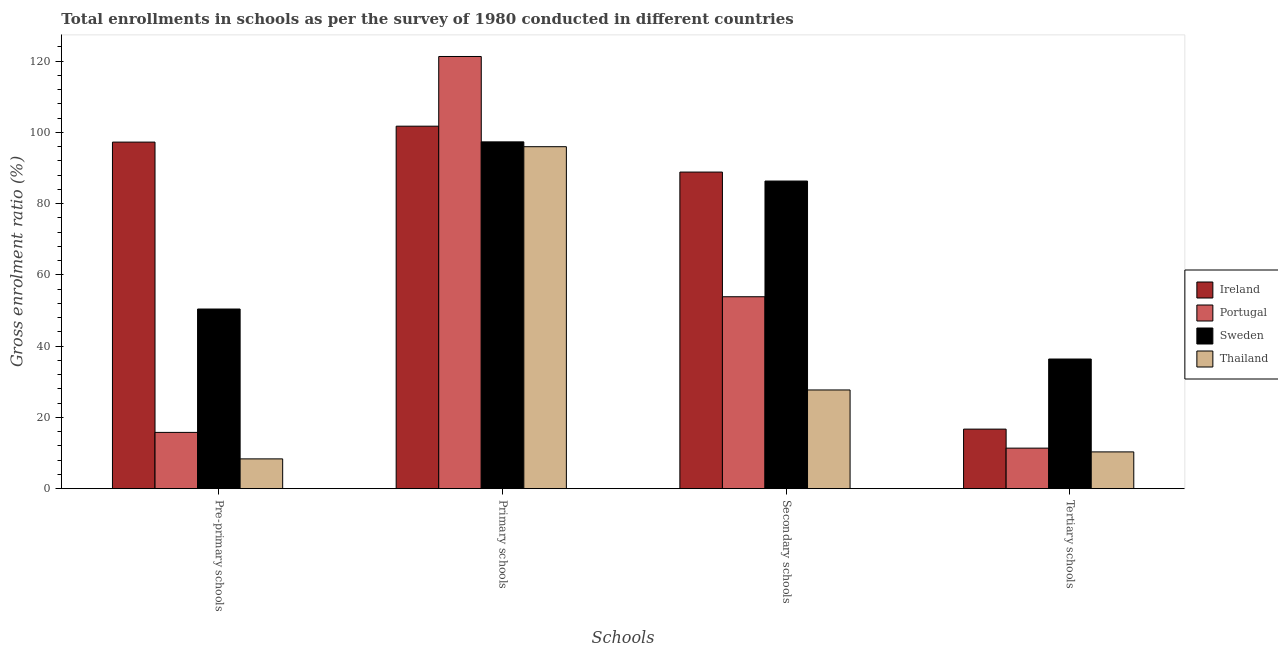How many different coloured bars are there?
Keep it short and to the point. 4. How many groups of bars are there?
Keep it short and to the point. 4. Are the number of bars on each tick of the X-axis equal?
Your answer should be very brief. Yes. How many bars are there on the 1st tick from the right?
Give a very brief answer. 4. What is the label of the 2nd group of bars from the left?
Make the answer very short. Primary schools. What is the gross enrolment ratio in secondary schools in Thailand?
Give a very brief answer. 27.7. Across all countries, what is the maximum gross enrolment ratio in tertiary schools?
Make the answer very short. 36.38. Across all countries, what is the minimum gross enrolment ratio in primary schools?
Ensure brevity in your answer.  95.97. In which country was the gross enrolment ratio in tertiary schools minimum?
Your answer should be compact. Thailand. What is the total gross enrolment ratio in primary schools in the graph?
Your answer should be very brief. 416.29. What is the difference between the gross enrolment ratio in secondary schools in Sweden and that in Ireland?
Provide a succinct answer. -2.52. What is the difference between the gross enrolment ratio in tertiary schools in Sweden and the gross enrolment ratio in pre-primary schools in Portugal?
Your answer should be very brief. 20.59. What is the average gross enrolment ratio in tertiary schools per country?
Offer a terse response. 18.7. What is the difference between the gross enrolment ratio in secondary schools and gross enrolment ratio in primary schools in Thailand?
Offer a terse response. -68.27. In how many countries, is the gross enrolment ratio in primary schools greater than 88 %?
Give a very brief answer. 4. What is the ratio of the gross enrolment ratio in primary schools in Portugal to that in Sweden?
Offer a very short reply. 1.25. Is the difference between the gross enrolment ratio in primary schools in Ireland and Thailand greater than the difference between the gross enrolment ratio in tertiary schools in Ireland and Thailand?
Give a very brief answer. No. What is the difference between the highest and the second highest gross enrolment ratio in pre-primary schools?
Your answer should be compact. 46.84. What is the difference between the highest and the lowest gross enrolment ratio in pre-primary schools?
Keep it short and to the point. 88.89. In how many countries, is the gross enrolment ratio in tertiary schools greater than the average gross enrolment ratio in tertiary schools taken over all countries?
Your answer should be very brief. 1. Is it the case that in every country, the sum of the gross enrolment ratio in tertiary schools and gross enrolment ratio in pre-primary schools is greater than the sum of gross enrolment ratio in secondary schools and gross enrolment ratio in primary schools?
Your answer should be compact. No. What does the 3rd bar from the left in Tertiary schools represents?
Offer a terse response. Sweden. What does the 2nd bar from the right in Secondary schools represents?
Your answer should be compact. Sweden. Is it the case that in every country, the sum of the gross enrolment ratio in pre-primary schools and gross enrolment ratio in primary schools is greater than the gross enrolment ratio in secondary schools?
Your answer should be very brief. Yes. How many countries are there in the graph?
Ensure brevity in your answer.  4. What is the difference between two consecutive major ticks on the Y-axis?
Provide a succinct answer. 20. Are the values on the major ticks of Y-axis written in scientific E-notation?
Keep it short and to the point. No. Does the graph contain any zero values?
Provide a short and direct response. No. Does the graph contain grids?
Provide a succinct answer. No. Where does the legend appear in the graph?
Give a very brief answer. Center right. How are the legend labels stacked?
Give a very brief answer. Vertical. What is the title of the graph?
Provide a short and direct response. Total enrollments in schools as per the survey of 1980 conducted in different countries. Does "Antigua and Barbuda" appear as one of the legend labels in the graph?
Offer a very short reply. No. What is the label or title of the X-axis?
Your answer should be very brief. Schools. What is the Gross enrolment ratio (%) of Ireland in Pre-primary schools?
Make the answer very short. 97.25. What is the Gross enrolment ratio (%) in Portugal in Pre-primary schools?
Your response must be concise. 15.79. What is the Gross enrolment ratio (%) in Sweden in Pre-primary schools?
Your response must be concise. 50.41. What is the Gross enrolment ratio (%) of Thailand in Pre-primary schools?
Offer a very short reply. 8.36. What is the Gross enrolment ratio (%) of Ireland in Primary schools?
Offer a terse response. 101.72. What is the Gross enrolment ratio (%) in Portugal in Primary schools?
Ensure brevity in your answer.  121.28. What is the Gross enrolment ratio (%) in Sweden in Primary schools?
Provide a succinct answer. 97.32. What is the Gross enrolment ratio (%) in Thailand in Primary schools?
Provide a short and direct response. 95.97. What is the Gross enrolment ratio (%) in Ireland in Secondary schools?
Your answer should be very brief. 88.84. What is the Gross enrolment ratio (%) of Portugal in Secondary schools?
Your response must be concise. 53.86. What is the Gross enrolment ratio (%) of Sweden in Secondary schools?
Provide a succinct answer. 86.33. What is the Gross enrolment ratio (%) of Thailand in Secondary schools?
Your response must be concise. 27.7. What is the Gross enrolment ratio (%) of Ireland in Tertiary schools?
Provide a short and direct response. 16.71. What is the Gross enrolment ratio (%) in Portugal in Tertiary schools?
Ensure brevity in your answer.  11.38. What is the Gross enrolment ratio (%) of Sweden in Tertiary schools?
Provide a short and direct response. 36.38. What is the Gross enrolment ratio (%) in Thailand in Tertiary schools?
Offer a very short reply. 10.32. Across all Schools, what is the maximum Gross enrolment ratio (%) in Ireland?
Offer a terse response. 101.72. Across all Schools, what is the maximum Gross enrolment ratio (%) in Portugal?
Provide a succinct answer. 121.28. Across all Schools, what is the maximum Gross enrolment ratio (%) in Sweden?
Your answer should be very brief. 97.32. Across all Schools, what is the maximum Gross enrolment ratio (%) in Thailand?
Your answer should be very brief. 95.97. Across all Schools, what is the minimum Gross enrolment ratio (%) in Ireland?
Offer a very short reply. 16.71. Across all Schools, what is the minimum Gross enrolment ratio (%) in Portugal?
Offer a very short reply. 11.38. Across all Schools, what is the minimum Gross enrolment ratio (%) of Sweden?
Make the answer very short. 36.38. Across all Schools, what is the minimum Gross enrolment ratio (%) in Thailand?
Your answer should be compact. 8.36. What is the total Gross enrolment ratio (%) of Ireland in the graph?
Ensure brevity in your answer.  304.53. What is the total Gross enrolment ratio (%) of Portugal in the graph?
Make the answer very short. 202.31. What is the total Gross enrolment ratio (%) in Sweden in the graph?
Keep it short and to the point. 270.44. What is the total Gross enrolment ratio (%) of Thailand in the graph?
Offer a terse response. 142.34. What is the difference between the Gross enrolment ratio (%) of Ireland in Pre-primary schools and that in Primary schools?
Make the answer very short. -4.47. What is the difference between the Gross enrolment ratio (%) of Portugal in Pre-primary schools and that in Primary schools?
Provide a succinct answer. -105.49. What is the difference between the Gross enrolment ratio (%) in Sweden in Pre-primary schools and that in Primary schools?
Your answer should be very brief. -46.91. What is the difference between the Gross enrolment ratio (%) of Thailand in Pre-primary schools and that in Primary schools?
Provide a short and direct response. -87.61. What is the difference between the Gross enrolment ratio (%) of Ireland in Pre-primary schools and that in Secondary schools?
Your answer should be very brief. 8.41. What is the difference between the Gross enrolment ratio (%) in Portugal in Pre-primary schools and that in Secondary schools?
Offer a very short reply. -38.07. What is the difference between the Gross enrolment ratio (%) in Sweden in Pre-primary schools and that in Secondary schools?
Ensure brevity in your answer.  -35.92. What is the difference between the Gross enrolment ratio (%) of Thailand in Pre-primary schools and that in Secondary schools?
Offer a terse response. -19.34. What is the difference between the Gross enrolment ratio (%) of Ireland in Pre-primary schools and that in Tertiary schools?
Your answer should be compact. 80.54. What is the difference between the Gross enrolment ratio (%) in Portugal in Pre-primary schools and that in Tertiary schools?
Your answer should be very brief. 4.41. What is the difference between the Gross enrolment ratio (%) in Sweden in Pre-primary schools and that in Tertiary schools?
Your answer should be compact. 14.03. What is the difference between the Gross enrolment ratio (%) of Thailand in Pre-primary schools and that in Tertiary schools?
Offer a terse response. -1.96. What is the difference between the Gross enrolment ratio (%) of Ireland in Primary schools and that in Secondary schools?
Ensure brevity in your answer.  12.88. What is the difference between the Gross enrolment ratio (%) of Portugal in Primary schools and that in Secondary schools?
Ensure brevity in your answer.  67.42. What is the difference between the Gross enrolment ratio (%) of Sweden in Primary schools and that in Secondary schools?
Make the answer very short. 10.99. What is the difference between the Gross enrolment ratio (%) of Thailand in Primary schools and that in Secondary schools?
Provide a succinct answer. 68.27. What is the difference between the Gross enrolment ratio (%) in Ireland in Primary schools and that in Tertiary schools?
Your answer should be compact. 85.01. What is the difference between the Gross enrolment ratio (%) of Portugal in Primary schools and that in Tertiary schools?
Make the answer very short. 109.9. What is the difference between the Gross enrolment ratio (%) in Sweden in Primary schools and that in Tertiary schools?
Your response must be concise. 60.94. What is the difference between the Gross enrolment ratio (%) in Thailand in Primary schools and that in Tertiary schools?
Provide a succinct answer. 85.65. What is the difference between the Gross enrolment ratio (%) of Ireland in Secondary schools and that in Tertiary schools?
Make the answer very short. 72.13. What is the difference between the Gross enrolment ratio (%) of Portugal in Secondary schools and that in Tertiary schools?
Offer a very short reply. 42.48. What is the difference between the Gross enrolment ratio (%) of Sweden in Secondary schools and that in Tertiary schools?
Provide a short and direct response. 49.95. What is the difference between the Gross enrolment ratio (%) in Thailand in Secondary schools and that in Tertiary schools?
Your answer should be very brief. 17.38. What is the difference between the Gross enrolment ratio (%) of Ireland in Pre-primary schools and the Gross enrolment ratio (%) of Portugal in Primary schools?
Keep it short and to the point. -24.03. What is the difference between the Gross enrolment ratio (%) of Ireland in Pre-primary schools and the Gross enrolment ratio (%) of Sweden in Primary schools?
Provide a succinct answer. -0.06. What is the difference between the Gross enrolment ratio (%) in Ireland in Pre-primary schools and the Gross enrolment ratio (%) in Thailand in Primary schools?
Keep it short and to the point. 1.29. What is the difference between the Gross enrolment ratio (%) of Portugal in Pre-primary schools and the Gross enrolment ratio (%) of Sweden in Primary schools?
Make the answer very short. -81.53. What is the difference between the Gross enrolment ratio (%) in Portugal in Pre-primary schools and the Gross enrolment ratio (%) in Thailand in Primary schools?
Your answer should be very brief. -80.17. What is the difference between the Gross enrolment ratio (%) of Sweden in Pre-primary schools and the Gross enrolment ratio (%) of Thailand in Primary schools?
Give a very brief answer. -45.55. What is the difference between the Gross enrolment ratio (%) of Ireland in Pre-primary schools and the Gross enrolment ratio (%) of Portugal in Secondary schools?
Your answer should be very brief. 43.39. What is the difference between the Gross enrolment ratio (%) of Ireland in Pre-primary schools and the Gross enrolment ratio (%) of Sweden in Secondary schools?
Offer a very short reply. 10.93. What is the difference between the Gross enrolment ratio (%) in Ireland in Pre-primary schools and the Gross enrolment ratio (%) in Thailand in Secondary schools?
Ensure brevity in your answer.  69.55. What is the difference between the Gross enrolment ratio (%) in Portugal in Pre-primary schools and the Gross enrolment ratio (%) in Sweden in Secondary schools?
Provide a short and direct response. -70.54. What is the difference between the Gross enrolment ratio (%) of Portugal in Pre-primary schools and the Gross enrolment ratio (%) of Thailand in Secondary schools?
Ensure brevity in your answer.  -11.91. What is the difference between the Gross enrolment ratio (%) of Sweden in Pre-primary schools and the Gross enrolment ratio (%) of Thailand in Secondary schools?
Provide a succinct answer. 22.71. What is the difference between the Gross enrolment ratio (%) of Ireland in Pre-primary schools and the Gross enrolment ratio (%) of Portugal in Tertiary schools?
Provide a succinct answer. 85.88. What is the difference between the Gross enrolment ratio (%) in Ireland in Pre-primary schools and the Gross enrolment ratio (%) in Sweden in Tertiary schools?
Your answer should be very brief. 60.87. What is the difference between the Gross enrolment ratio (%) of Ireland in Pre-primary schools and the Gross enrolment ratio (%) of Thailand in Tertiary schools?
Your answer should be compact. 86.93. What is the difference between the Gross enrolment ratio (%) in Portugal in Pre-primary schools and the Gross enrolment ratio (%) in Sweden in Tertiary schools?
Provide a short and direct response. -20.59. What is the difference between the Gross enrolment ratio (%) of Portugal in Pre-primary schools and the Gross enrolment ratio (%) of Thailand in Tertiary schools?
Give a very brief answer. 5.47. What is the difference between the Gross enrolment ratio (%) of Sweden in Pre-primary schools and the Gross enrolment ratio (%) of Thailand in Tertiary schools?
Your response must be concise. 40.09. What is the difference between the Gross enrolment ratio (%) of Ireland in Primary schools and the Gross enrolment ratio (%) of Portugal in Secondary schools?
Your response must be concise. 47.86. What is the difference between the Gross enrolment ratio (%) in Ireland in Primary schools and the Gross enrolment ratio (%) in Sweden in Secondary schools?
Your answer should be very brief. 15.39. What is the difference between the Gross enrolment ratio (%) in Ireland in Primary schools and the Gross enrolment ratio (%) in Thailand in Secondary schools?
Your response must be concise. 74.02. What is the difference between the Gross enrolment ratio (%) of Portugal in Primary schools and the Gross enrolment ratio (%) of Sweden in Secondary schools?
Your answer should be very brief. 34.95. What is the difference between the Gross enrolment ratio (%) in Portugal in Primary schools and the Gross enrolment ratio (%) in Thailand in Secondary schools?
Your answer should be very brief. 93.58. What is the difference between the Gross enrolment ratio (%) of Sweden in Primary schools and the Gross enrolment ratio (%) of Thailand in Secondary schools?
Offer a terse response. 69.62. What is the difference between the Gross enrolment ratio (%) in Ireland in Primary schools and the Gross enrolment ratio (%) in Portugal in Tertiary schools?
Provide a succinct answer. 90.34. What is the difference between the Gross enrolment ratio (%) of Ireland in Primary schools and the Gross enrolment ratio (%) of Sweden in Tertiary schools?
Your answer should be compact. 65.34. What is the difference between the Gross enrolment ratio (%) of Ireland in Primary schools and the Gross enrolment ratio (%) of Thailand in Tertiary schools?
Keep it short and to the point. 91.4. What is the difference between the Gross enrolment ratio (%) in Portugal in Primary schools and the Gross enrolment ratio (%) in Sweden in Tertiary schools?
Provide a succinct answer. 84.9. What is the difference between the Gross enrolment ratio (%) in Portugal in Primary schools and the Gross enrolment ratio (%) in Thailand in Tertiary schools?
Your answer should be very brief. 110.96. What is the difference between the Gross enrolment ratio (%) of Sweden in Primary schools and the Gross enrolment ratio (%) of Thailand in Tertiary schools?
Ensure brevity in your answer.  87. What is the difference between the Gross enrolment ratio (%) in Ireland in Secondary schools and the Gross enrolment ratio (%) in Portugal in Tertiary schools?
Offer a terse response. 77.47. What is the difference between the Gross enrolment ratio (%) in Ireland in Secondary schools and the Gross enrolment ratio (%) in Sweden in Tertiary schools?
Keep it short and to the point. 52.46. What is the difference between the Gross enrolment ratio (%) of Ireland in Secondary schools and the Gross enrolment ratio (%) of Thailand in Tertiary schools?
Your answer should be very brief. 78.52. What is the difference between the Gross enrolment ratio (%) of Portugal in Secondary schools and the Gross enrolment ratio (%) of Sweden in Tertiary schools?
Offer a terse response. 17.48. What is the difference between the Gross enrolment ratio (%) in Portugal in Secondary schools and the Gross enrolment ratio (%) in Thailand in Tertiary schools?
Make the answer very short. 43.54. What is the difference between the Gross enrolment ratio (%) of Sweden in Secondary schools and the Gross enrolment ratio (%) of Thailand in Tertiary schools?
Provide a short and direct response. 76.01. What is the average Gross enrolment ratio (%) in Ireland per Schools?
Offer a terse response. 76.13. What is the average Gross enrolment ratio (%) in Portugal per Schools?
Give a very brief answer. 50.58. What is the average Gross enrolment ratio (%) of Sweden per Schools?
Keep it short and to the point. 67.61. What is the average Gross enrolment ratio (%) in Thailand per Schools?
Provide a short and direct response. 35.59. What is the difference between the Gross enrolment ratio (%) in Ireland and Gross enrolment ratio (%) in Portugal in Pre-primary schools?
Provide a short and direct response. 81.46. What is the difference between the Gross enrolment ratio (%) in Ireland and Gross enrolment ratio (%) in Sweden in Pre-primary schools?
Offer a terse response. 46.84. What is the difference between the Gross enrolment ratio (%) in Ireland and Gross enrolment ratio (%) in Thailand in Pre-primary schools?
Offer a terse response. 88.89. What is the difference between the Gross enrolment ratio (%) of Portugal and Gross enrolment ratio (%) of Sweden in Pre-primary schools?
Give a very brief answer. -34.62. What is the difference between the Gross enrolment ratio (%) of Portugal and Gross enrolment ratio (%) of Thailand in Pre-primary schools?
Provide a succinct answer. 7.43. What is the difference between the Gross enrolment ratio (%) of Sweden and Gross enrolment ratio (%) of Thailand in Pre-primary schools?
Ensure brevity in your answer.  42.05. What is the difference between the Gross enrolment ratio (%) of Ireland and Gross enrolment ratio (%) of Portugal in Primary schools?
Ensure brevity in your answer.  -19.56. What is the difference between the Gross enrolment ratio (%) in Ireland and Gross enrolment ratio (%) in Sweden in Primary schools?
Ensure brevity in your answer.  4.4. What is the difference between the Gross enrolment ratio (%) in Ireland and Gross enrolment ratio (%) in Thailand in Primary schools?
Provide a short and direct response. 5.76. What is the difference between the Gross enrolment ratio (%) of Portugal and Gross enrolment ratio (%) of Sweden in Primary schools?
Offer a terse response. 23.96. What is the difference between the Gross enrolment ratio (%) in Portugal and Gross enrolment ratio (%) in Thailand in Primary schools?
Ensure brevity in your answer.  25.31. What is the difference between the Gross enrolment ratio (%) of Sweden and Gross enrolment ratio (%) of Thailand in Primary schools?
Your response must be concise. 1.35. What is the difference between the Gross enrolment ratio (%) in Ireland and Gross enrolment ratio (%) in Portugal in Secondary schools?
Ensure brevity in your answer.  34.98. What is the difference between the Gross enrolment ratio (%) of Ireland and Gross enrolment ratio (%) of Sweden in Secondary schools?
Provide a short and direct response. 2.52. What is the difference between the Gross enrolment ratio (%) of Ireland and Gross enrolment ratio (%) of Thailand in Secondary schools?
Provide a succinct answer. 61.14. What is the difference between the Gross enrolment ratio (%) of Portugal and Gross enrolment ratio (%) of Sweden in Secondary schools?
Your answer should be very brief. -32.47. What is the difference between the Gross enrolment ratio (%) of Portugal and Gross enrolment ratio (%) of Thailand in Secondary schools?
Provide a succinct answer. 26.16. What is the difference between the Gross enrolment ratio (%) of Sweden and Gross enrolment ratio (%) of Thailand in Secondary schools?
Offer a very short reply. 58.63. What is the difference between the Gross enrolment ratio (%) of Ireland and Gross enrolment ratio (%) of Portugal in Tertiary schools?
Make the answer very short. 5.33. What is the difference between the Gross enrolment ratio (%) in Ireland and Gross enrolment ratio (%) in Sweden in Tertiary schools?
Offer a terse response. -19.67. What is the difference between the Gross enrolment ratio (%) in Ireland and Gross enrolment ratio (%) in Thailand in Tertiary schools?
Your answer should be compact. 6.39. What is the difference between the Gross enrolment ratio (%) of Portugal and Gross enrolment ratio (%) of Sweden in Tertiary schools?
Your answer should be very brief. -25. What is the difference between the Gross enrolment ratio (%) of Portugal and Gross enrolment ratio (%) of Thailand in Tertiary schools?
Your answer should be compact. 1.06. What is the difference between the Gross enrolment ratio (%) of Sweden and Gross enrolment ratio (%) of Thailand in Tertiary schools?
Your response must be concise. 26.06. What is the ratio of the Gross enrolment ratio (%) of Ireland in Pre-primary schools to that in Primary schools?
Provide a short and direct response. 0.96. What is the ratio of the Gross enrolment ratio (%) in Portugal in Pre-primary schools to that in Primary schools?
Offer a terse response. 0.13. What is the ratio of the Gross enrolment ratio (%) in Sweden in Pre-primary schools to that in Primary schools?
Your answer should be very brief. 0.52. What is the ratio of the Gross enrolment ratio (%) of Thailand in Pre-primary schools to that in Primary schools?
Your answer should be compact. 0.09. What is the ratio of the Gross enrolment ratio (%) in Ireland in Pre-primary schools to that in Secondary schools?
Offer a very short reply. 1.09. What is the ratio of the Gross enrolment ratio (%) in Portugal in Pre-primary schools to that in Secondary schools?
Your response must be concise. 0.29. What is the ratio of the Gross enrolment ratio (%) of Sweden in Pre-primary schools to that in Secondary schools?
Offer a very short reply. 0.58. What is the ratio of the Gross enrolment ratio (%) of Thailand in Pre-primary schools to that in Secondary schools?
Ensure brevity in your answer.  0.3. What is the ratio of the Gross enrolment ratio (%) of Ireland in Pre-primary schools to that in Tertiary schools?
Make the answer very short. 5.82. What is the ratio of the Gross enrolment ratio (%) in Portugal in Pre-primary schools to that in Tertiary schools?
Make the answer very short. 1.39. What is the ratio of the Gross enrolment ratio (%) in Sweden in Pre-primary schools to that in Tertiary schools?
Offer a very short reply. 1.39. What is the ratio of the Gross enrolment ratio (%) of Thailand in Pre-primary schools to that in Tertiary schools?
Make the answer very short. 0.81. What is the ratio of the Gross enrolment ratio (%) of Ireland in Primary schools to that in Secondary schools?
Provide a succinct answer. 1.15. What is the ratio of the Gross enrolment ratio (%) in Portugal in Primary schools to that in Secondary schools?
Offer a terse response. 2.25. What is the ratio of the Gross enrolment ratio (%) of Sweden in Primary schools to that in Secondary schools?
Offer a very short reply. 1.13. What is the ratio of the Gross enrolment ratio (%) of Thailand in Primary schools to that in Secondary schools?
Offer a terse response. 3.46. What is the ratio of the Gross enrolment ratio (%) in Ireland in Primary schools to that in Tertiary schools?
Your answer should be very brief. 6.09. What is the ratio of the Gross enrolment ratio (%) of Portugal in Primary schools to that in Tertiary schools?
Make the answer very short. 10.66. What is the ratio of the Gross enrolment ratio (%) in Sweden in Primary schools to that in Tertiary schools?
Provide a succinct answer. 2.67. What is the ratio of the Gross enrolment ratio (%) in Thailand in Primary schools to that in Tertiary schools?
Keep it short and to the point. 9.3. What is the ratio of the Gross enrolment ratio (%) in Ireland in Secondary schools to that in Tertiary schools?
Provide a succinct answer. 5.32. What is the ratio of the Gross enrolment ratio (%) in Portugal in Secondary schools to that in Tertiary schools?
Offer a terse response. 4.73. What is the ratio of the Gross enrolment ratio (%) in Sweden in Secondary schools to that in Tertiary schools?
Your response must be concise. 2.37. What is the ratio of the Gross enrolment ratio (%) in Thailand in Secondary schools to that in Tertiary schools?
Give a very brief answer. 2.68. What is the difference between the highest and the second highest Gross enrolment ratio (%) of Ireland?
Your answer should be compact. 4.47. What is the difference between the highest and the second highest Gross enrolment ratio (%) of Portugal?
Your answer should be compact. 67.42. What is the difference between the highest and the second highest Gross enrolment ratio (%) in Sweden?
Give a very brief answer. 10.99. What is the difference between the highest and the second highest Gross enrolment ratio (%) in Thailand?
Offer a very short reply. 68.27. What is the difference between the highest and the lowest Gross enrolment ratio (%) of Ireland?
Ensure brevity in your answer.  85.01. What is the difference between the highest and the lowest Gross enrolment ratio (%) in Portugal?
Offer a terse response. 109.9. What is the difference between the highest and the lowest Gross enrolment ratio (%) of Sweden?
Your answer should be very brief. 60.94. What is the difference between the highest and the lowest Gross enrolment ratio (%) in Thailand?
Your response must be concise. 87.61. 